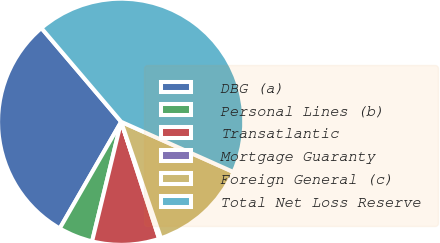Convert chart to OTSL. <chart><loc_0><loc_0><loc_500><loc_500><pie_chart><fcel>DBG (a)<fcel>Personal Lines (b)<fcel>Transatlantic<fcel>Mortgage Guaranty<fcel>Foreign General (c)<fcel>Total Net Loss Reserve<nl><fcel>30.46%<fcel>4.52%<fcel>8.79%<fcel>0.25%<fcel>13.06%<fcel>42.92%<nl></chart> 